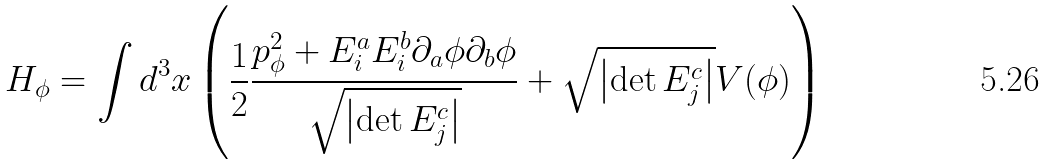Convert formula to latex. <formula><loc_0><loc_0><loc_500><loc_500>H _ { \phi } = \int d ^ { 3 } x \left ( \frac { 1 } { 2 } \frac { p _ { \phi } ^ { 2 } + E ^ { a } _ { i } E ^ { b } _ { i } \partial _ { a } \phi \partial _ { b } \phi } { \sqrt { \left | \det E ^ { c } _ { j } \right | } } + \sqrt { \left | \det E ^ { c } _ { j } \right | } V ( \phi ) \right )</formula> 